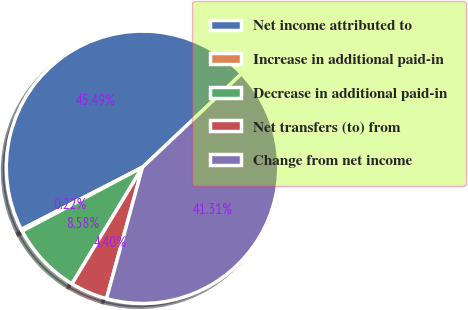Convert chart to OTSL. <chart><loc_0><loc_0><loc_500><loc_500><pie_chart><fcel>Net income attributed to<fcel>Increase in additional paid-in<fcel>Decrease in additional paid-in<fcel>Net transfers (to) from<fcel>Change from net income<nl><fcel>45.49%<fcel>0.22%<fcel>8.58%<fcel>4.4%<fcel>41.31%<nl></chart> 